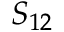<formula> <loc_0><loc_0><loc_500><loc_500>S _ { 1 2 }</formula> 